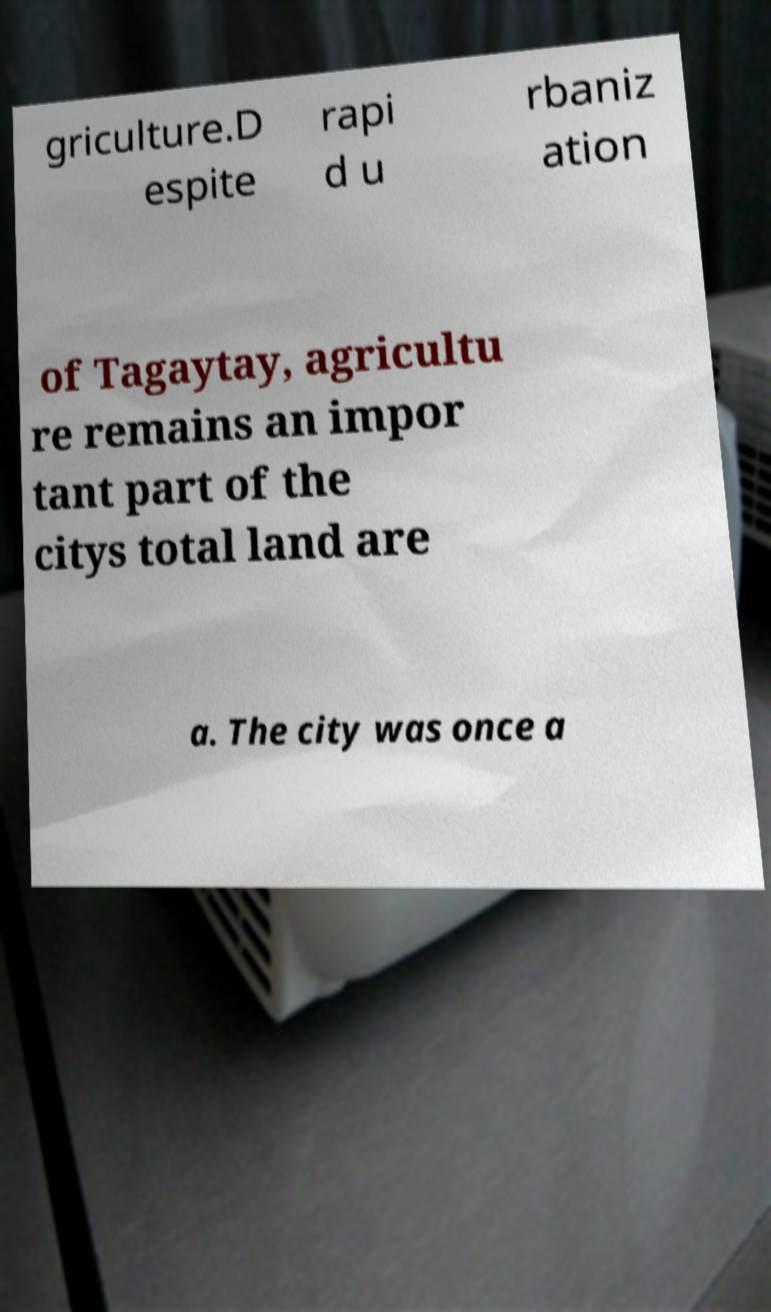Can you read and provide the text displayed in the image?This photo seems to have some interesting text. Can you extract and type it out for me? griculture.D espite rapi d u rbaniz ation of Tagaytay, agricultu re remains an impor tant part of the citys total land are a. The city was once a 